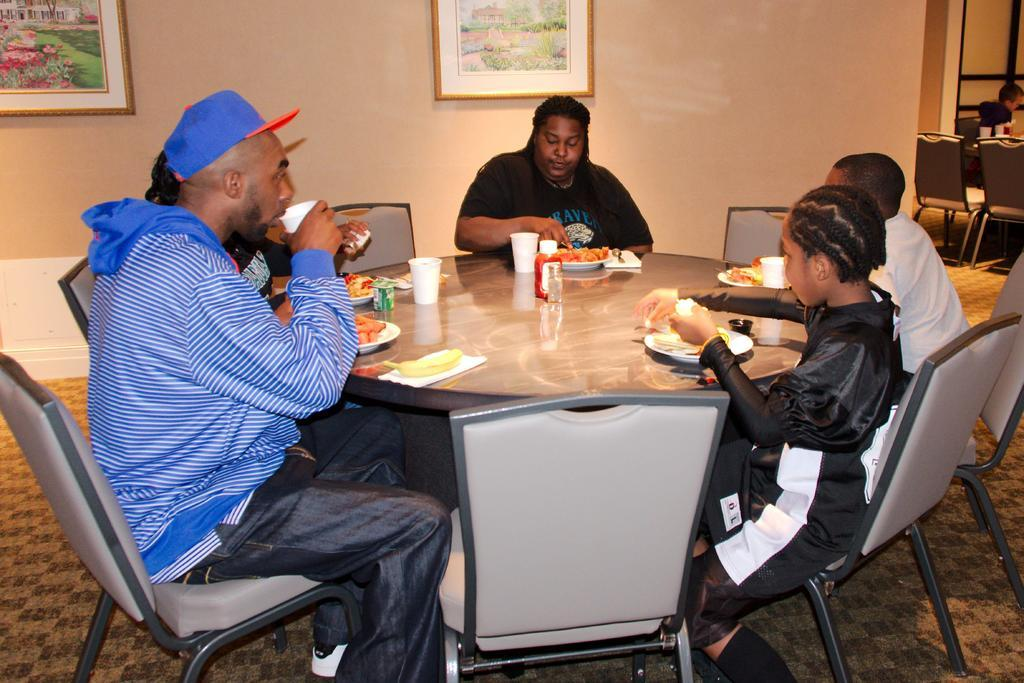How many people are in the image? There is a group of persons in the image. What are the people in the image doing? The group of persons is sitting at a dining table and having food and drinks. What can be seen on the wall in the image? There are paintings on the wall in the image. What type of stone is used to create the pump in the image? There is no stone or pump present in the image. 